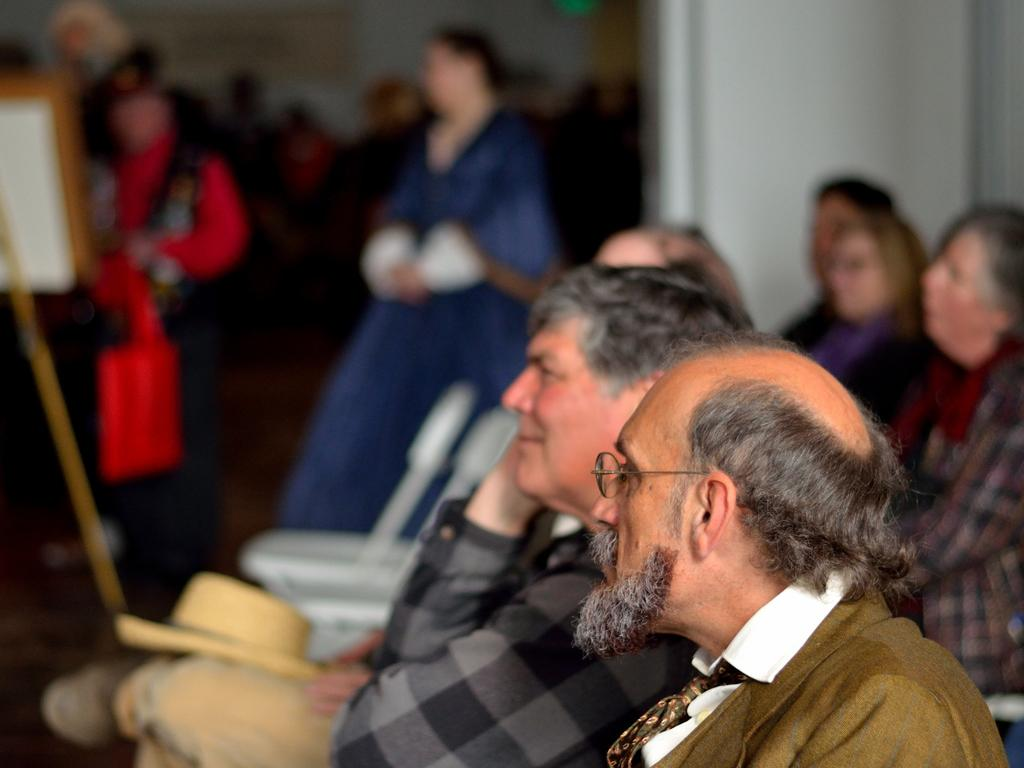What are the people in the bottom of the image doing? The people in the bottom of the image are sitting. What are the people in the background of the image doing? The people in the background of the image are standing. What type of popcorn is being served in the image? There is no popcorn present in the image. What kind of lumber is visible in the image? There is no lumber present in the image. 